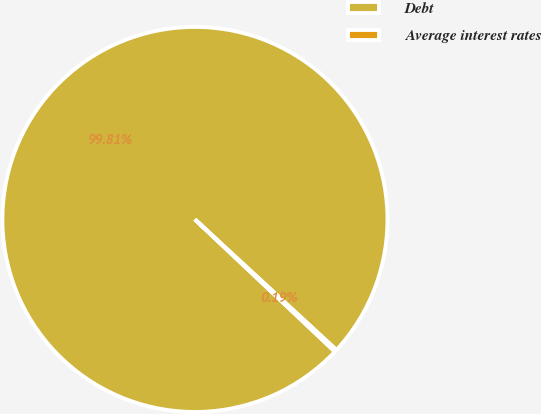<chart> <loc_0><loc_0><loc_500><loc_500><pie_chart><fcel>Debt<fcel>Average interest rates<nl><fcel>99.81%<fcel>0.19%<nl></chart> 